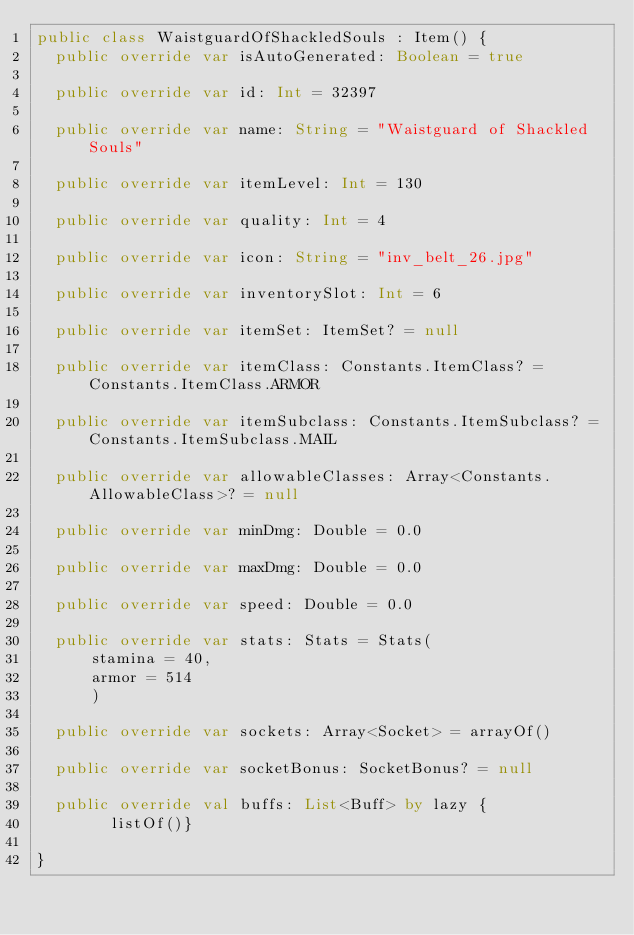Convert code to text. <code><loc_0><loc_0><loc_500><loc_500><_Kotlin_>public class WaistguardOfShackledSouls : Item() {
  public override var isAutoGenerated: Boolean = true

  public override var id: Int = 32397

  public override var name: String = "Waistguard of Shackled Souls"

  public override var itemLevel: Int = 130

  public override var quality: Int = 4

  public override var icon: String = "inv_belt_26.jpg"

  public override var inventorySlot: Int = 6

  public override var itemSet: ItemSet? = null

  public override var itemClass: Constants.ItemClass? = Constants.ItemClass.ARMOR

  public override var itemSubclass: Constants.ItemSubclass? = Constants.ItemSubclass.MAIL

  public override var allowableClasses: Array<Constants.AllowableClass>? = null

  public override var minDmg: Double = 0.0

  public override var maxDmg: Double = 0.0

  public override var speed: Double = 0.0

  public override var stats: Stats = Stats(
      stamina = 40,
      armor = 514
      )

  public override var sockets: Array<Socket> = arrayOf()

  public override var socketBonus: SocketBonus? = null

  public override val buffs: List<Buff> by lazy {
        listOf()}

}
</code> 